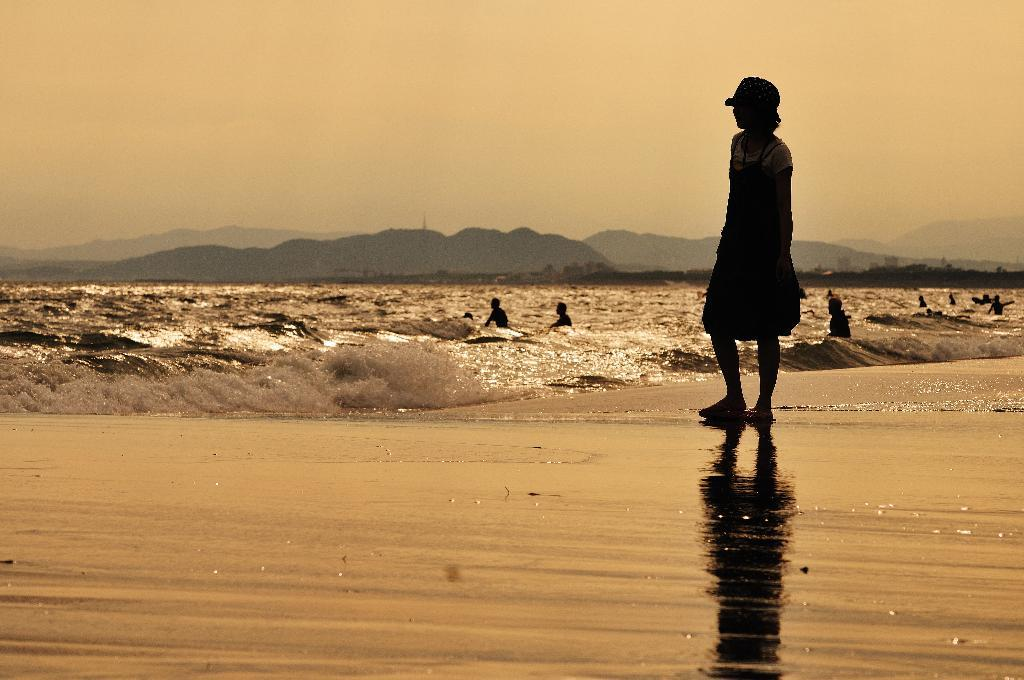What are the people in the image doing? The people in the image are in the water. Can you describe the girl in the image? The girl is standing in the image and is wearing a cap. What can be seen in the background of the image? There are mountains and the sky visible in the background of the image. How many crows are sitting on the clock in the image? There is no clock or crow present in the image. What type of waves can be seen in the image? There are no waves visible in the image; it features people in the water with a girl standing nearby. 